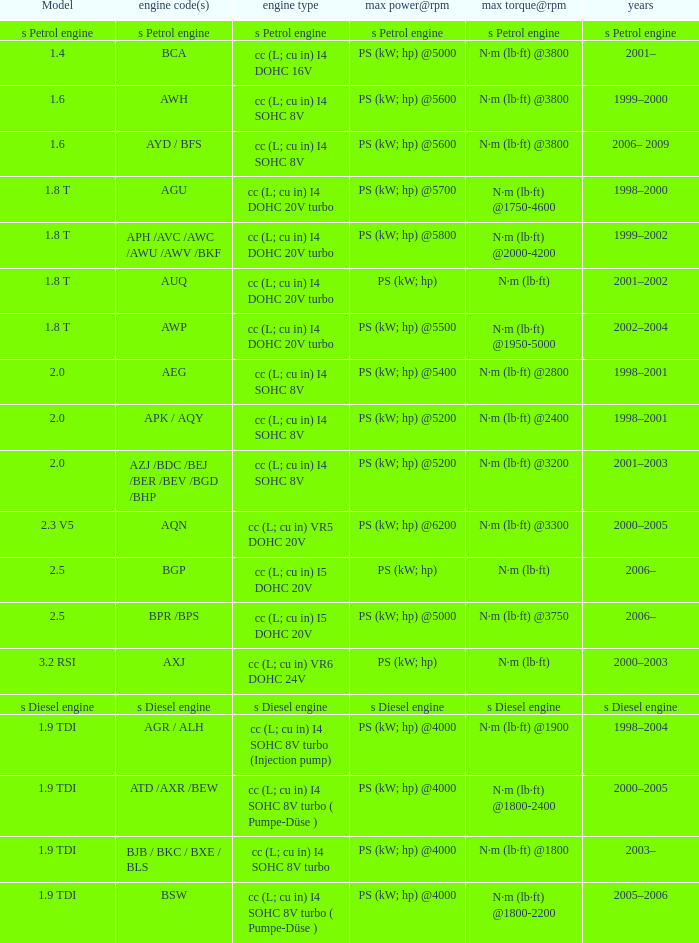Which engine type was used in the model 2.3 v5? Cc (l; cu in) vr5 dohc 20v. 